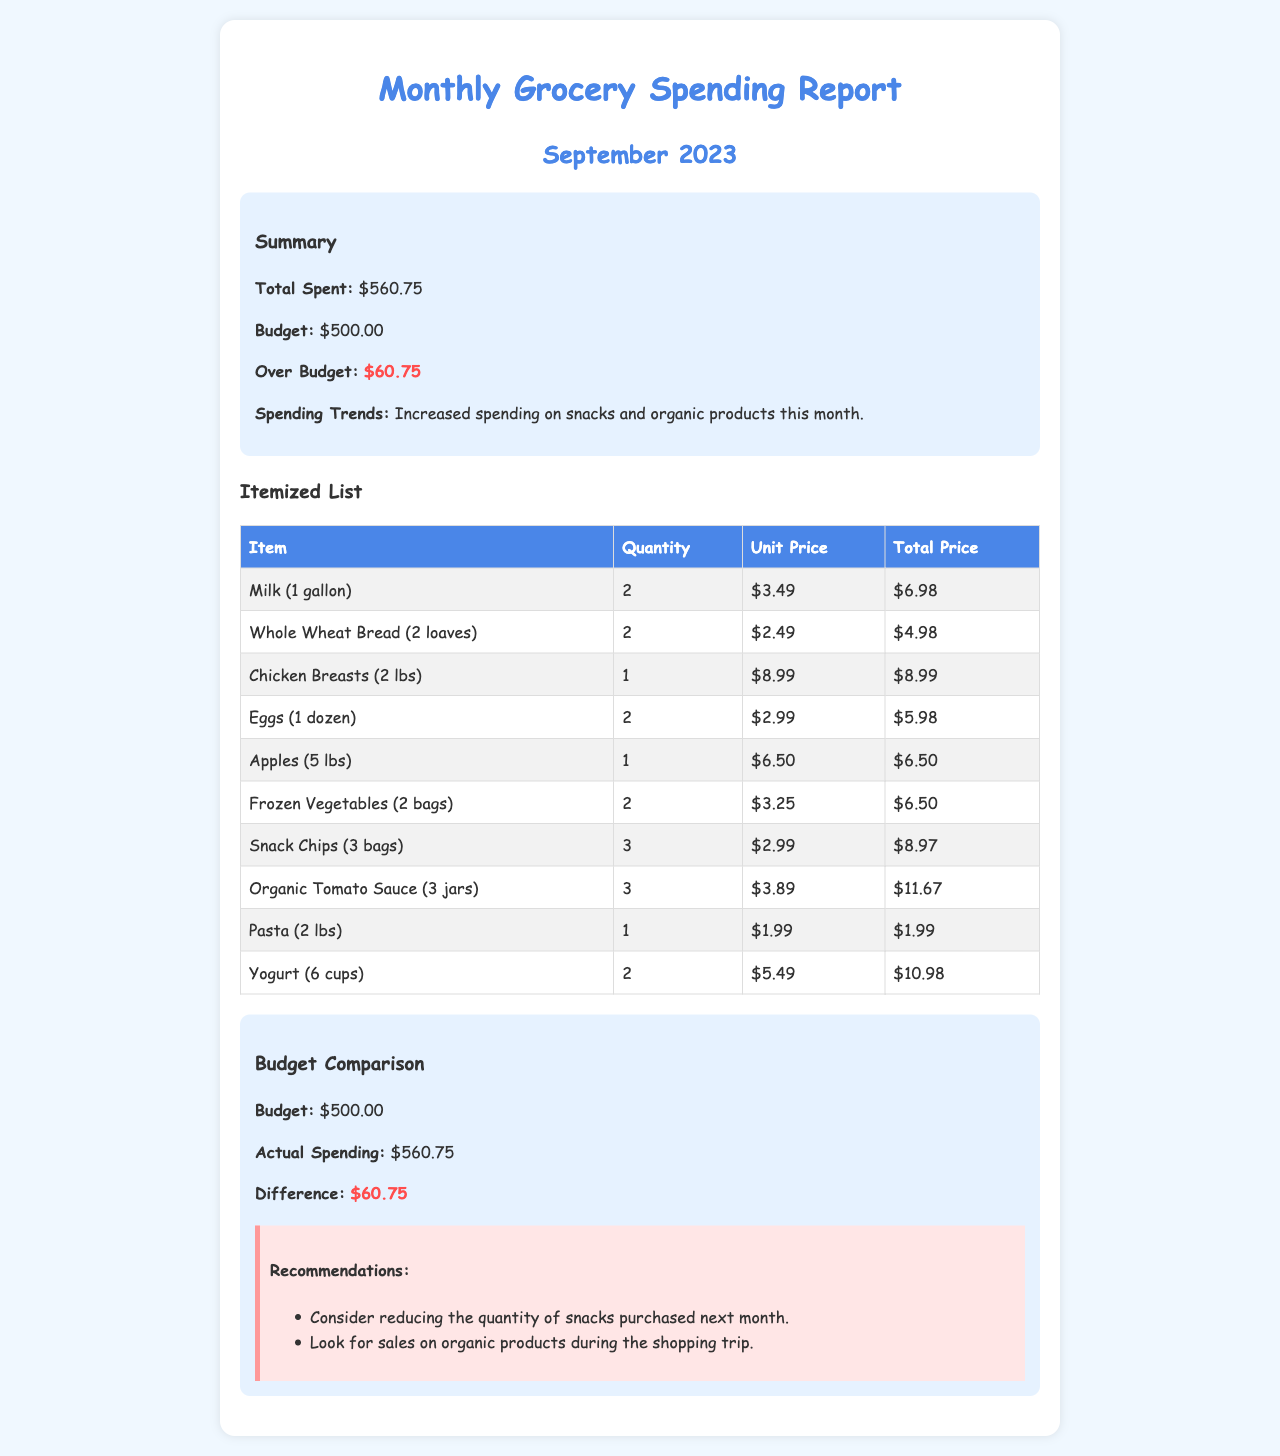What is the total spent on groceries in September 2023? The total spent on groceries is stated in the summary section, which lists it as $560.75.
Answer: $560.75 What was the budget for September 2023? The document specifies the budget for September as $500.00 in the summary section.
Answer: $500.00 How much did the family overspend in September 2023? The over budget amount is provided in the summary, which indicates it as $60.75.
Answer: $60.75 Which category showed increased spending this month? The summary mentions that there was increased spending on snacks and organic products this month.
Answer: Snacks and organic products What is the unit price of Milk? The itemized list shows that the unit price of Milk is $3.49.
Answer: $3.49 How many bags of frozen vegetables were purchased? The itemized list states that 2 bags of Frozen Vegetables were purchased.
Answer: 2 bags What item had the highest total price? Looking at the itemized list, Organic Tomato Sauce has the highest total price of $11.67.
Answer: Organic Tomato Sauce What is one of the recommendations for next month? The recommendations suggest reducing the quantity of snacks purchased next month.
Answer: Reduce snacks What was the total price for Chicken Breasts? The total price for Chicken Breasts is listed as $8.99 in the itemized list.
Answer: $8.99 What is the difference between the budget and actual spending? The document calculates the difference in the budget comparison section, which is $60.75.
Answer: $60.75 